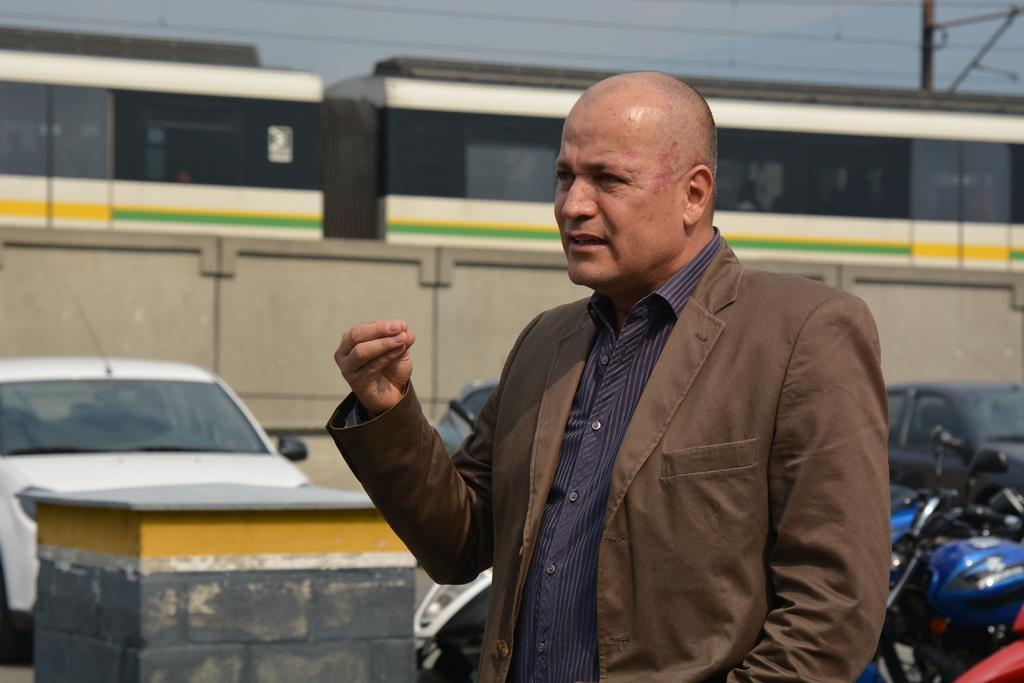Describe this image in one or two sentences. There is a man. In the back there are many vehicles. Also there is a stand with brick wall. In the background there is a wall. And there is a train. Also there is sky and there is an electric pole with wires. 